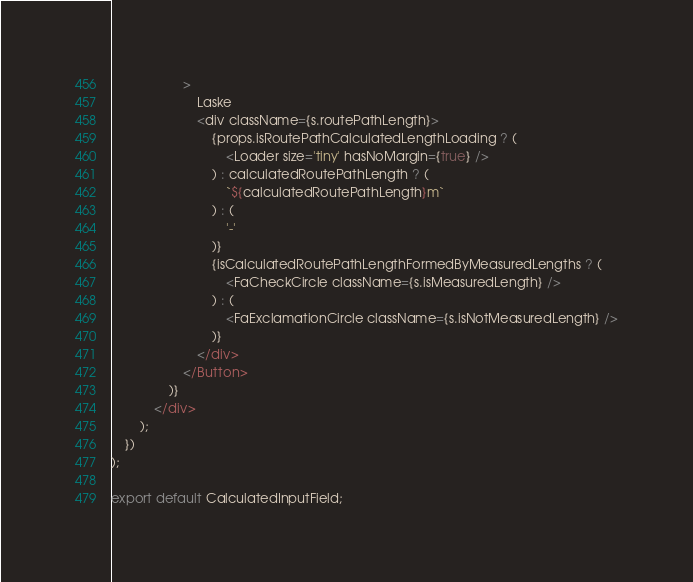Convert code to text. <code><loc_0><loc_0><loc_500><loc_500><_TypeScript_>                    >
                        Laske
                        <div className={s.routePathLength}>
                            {props.isRoutePathCalculatedLengthLoading ? (
                                <Loader size='tiny' hasNoMargin={true} />
                            ) : calculatedRoutePathLength ? (
                                `${calculatedRoutePathLength}m`
                            ) : (
                                '-'
                            )}
                            {isCalculatedRoutePathLengthFormedByMeasuredLengths ? (
                                <FaCheckCircle className={s.isMeasuredLength} />
                            ) : (
                                <FaExclamationCircle className={s.isNotMeasuredLength} />
                            )}
                        </div>
                    </Button>
                )}
            </div>
        );
    })
);

export default CalculatedInputField;
</code> 